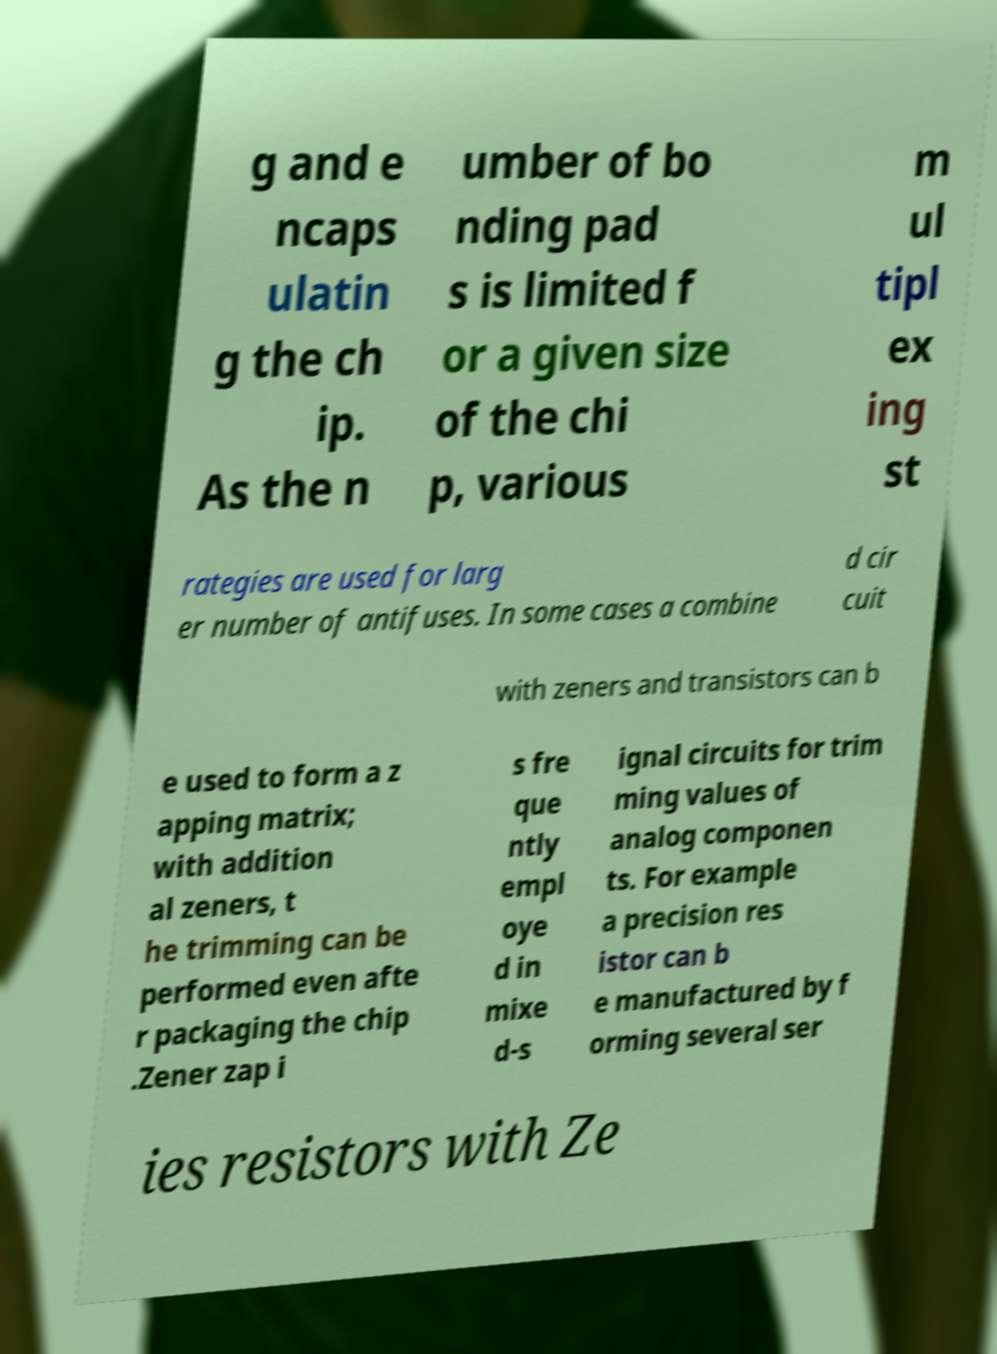What messages or text are displayed in this image? I need them in a readable, typed format. g and e ncaps ulatin g the ch ip. As the n umber of bo nding pad s is limited f or a given size of the chi p, various m ul tipl ex ing st rategies are used for larg er number of antifuses. In some cases a combine d cir cuit with zeners and transistors can b e used to form a z apping matrix; with addition al zeners, t he trimming can be performed even afte r packaging the chip .Zener zap i s fre que ntly empl oye d in mixe d-s ignal circuits for trim ming values of analog componen ts. For example a precision res istor can b e manufactured by f orming several ser ies resistors with Ze 